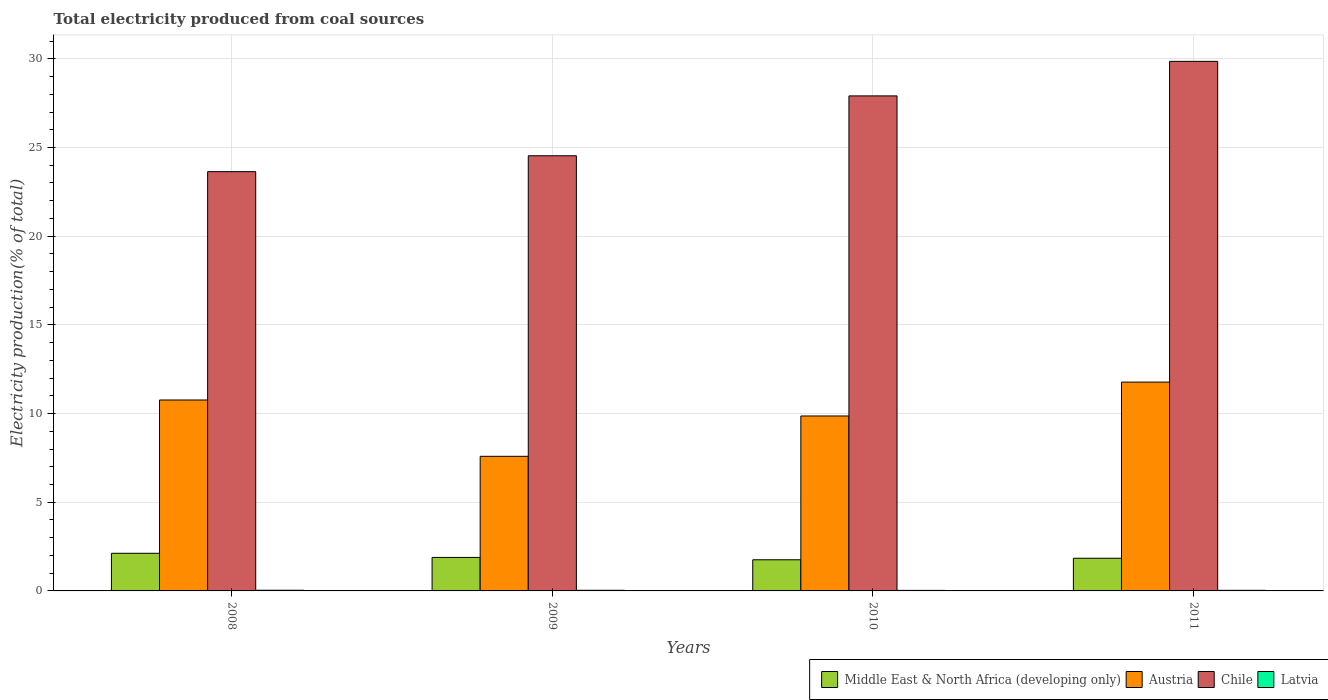Are the number of bars per tick equal to the number of legend labels?
Keep it short and to the point. Yes. Are the number of bars on each tick of the X-axis equal?
Ensure brevity in your answer.  Yes. How many bars are there on the 4th tick from the left?
Provide a succinct answer. 4. What is the label of the 3rd group of bars from the left?
Offer a very short reply. 2010. In how many cases, is the number of bars for a given year not equal to the number of legend labels?
Offer a very short reply. 0. What is the total electricity produced in Middle East & North Africa (developing only) in 2008?
Offer a very short reply. 2.12. Across all years, what is the maximum total electricity produced in Middle East & North Africa (developing only)?
Provide a succinct answer. 2.12. Across all years, what is the minimum total electricity produced in Austria?
Provide a succinct answer. 7.59. What is the total total electricity produced in Austria in the graph?
Your answer should be very brief. 39.99. What is the difference between the total electricity produced in Latvia in 2009 and that in 2011?
Ensure brevity in your answer.  0. What is the difference between the total electricity produced in Latvia in 2008 and the total electricity produced in Austria in 2009?
Provide a succinct answer. -7.55. What is the average total electricity produced in Latvia per year?
Your response must be concise. 0.03. In the year 2010, what is the difference between the total electricity produced in Middle East & North Africa (developing only) and total electricity produced in Chile?
Make the answer very short. -26.15. In how many years, is the total electricity produced in Latvia greater than 6 %?
Make the answer very short. 0. What is the ratio of the total electricity produced in Middle East & North Africa (developing only) in 2009 to that in 2011?
Your response must be concise. 1.03. Is the total electricity produced in Latvia in 2008 less than that in 2009?
Your response must be concise. No. What is the difference between the highest and the second highest total electricity produced in Austria?
Your response must be concise. 1.01. What is the difference between the highest and the lowest total electricity produced in Austria?
Offer a very short reply. 4.18. In how many years, is the total electricity produced in Latvia greater than the average total electricity produced in Latvia taken over all years?
Offer a very short reply. 2. Is it the case that in every year, the sum of the total electricity produced in Austria and total electricity produced in Chile is greater than the sum of total electricity produced in Middle East & North Africa (developing only) and total electricity produced in Latvia?
Keep it short and to the point. No. What does the 2nd bar from the left in 2008 represents?
Your response must be concise. Austria. What does the 1st bar from the right in 2008 represents?
Your answer should be compact. Latvia. Is it the case that in every year, the sum of the total electricity produced in Latvia and total electricity produced in Chile is greater than the total electricity produced in Austria?
Ensure brevity in your answer.  Yes. How many bars are there?
Offer a very short reply. 16. Are the values on the major ticks of Y-axis written in scientific E-notation?
Your answer should be compact. No. Does the graph contain any zero values?
Offer a very short reply. No. Where does the legend appear in the graph?
Give a very brief answer. Bottom right. What is the title of the graph?
Keep it short and to the point. Total electricity produced from coal sources. What is the label or title of the X-axis?
Ensure brevity in your answer.  Years. What is the Electricity production(% of total) in Middle East & North Africa (developing only) in 2008?
Your answer should be very brief. 2.12. What is the Electricity production(% of total) of Austria in 2008?
Provide a short and direct response. 10.76. What is the Electricity production(% of total) in Chile in 2008?
Give a very brief answer. 23.64. What is the Electricity production(% of total) in Latvia in 2008?
Offer a very short reply. 0.04. What is the Electricity production(% of total) in Middle East & North Africa (developing only) in 2009?
Provide a succinct answer. 1.89. What is the Electricity production(% of total) of Austria in 2009?
Your response must be concise. 7.59. What is the Electricity production(% of total) of Chile in 2009?
Keep it short and to the point. 24.53. What is the Electricity production(% of total) of Latvia in 2009?
Give a very brief answer. 0.04. What is the Electricity production(% of total) in Middle East & North Africa (developing only) in 2010?
Your response must be concise. 1.76. What is the Electricity production(% of total) of Austria in 2010?
Ensure brevity in your answer.  9.86. What is the Electricity production(% of total) of Chile in 2010?
Give a very brief answer. 27.91. What is the Electricity production(% of total) of Latvia in 2010?
Offer a terse response. 0.03. What is the Electricity production(% of total) of Middle East & North Africa (developing only) in 2011?
Provide a short and direct response. 1.84. What is the Electricity production(% of total) of Austria in 2011?
Provide a succinct answer. 11.77. What is the Electricity production(% of total) in Chile in 2011?
Make the answer very short. 29.86. What is the Electricity production(% of total) of Latvia in 2011?
Provide a short and direct response. 0.03. Across all years, what is the maximum Electricity production(% of total) of Middle East & North Africa (developing only)?
Your response must be concise. 2.12. Across all years, what is the maximum Electricity production(% of total) in Austria?
Make the answer very short. 11.77. Across all years, what is the maximum Electricity production(% of total) of Chile?
Make the answer very short. 29.86. Across all years, what is the maximum Electricity production(% of total) of Latvia?
Provide a succinct answer. 0.04. Across all years, what is the minimum Electricity production(% of total) of Middle East & North Africa (developing only)?
Provide a short and direct response. 1.76. Across all years, what is the minimum Electricity production(% of total) of Austria?
Your answer should be very brief. 7.59. Across all years, what is the minimum Electricity production(% of total) in Chile?
Your response must be concise. 23.64. Across all years, what is the minimum Electricity production(% of total) in Latvia?
Make the answer very short. 0.03. What is the total Electricity production(% of total) of Middle East & North Africa (developing only) in the graph?
Ensure brevity in your answer.  7.61. What is the total Electricity production(% of total) of Austria in the graph?
Your answer should be compact. 39.99. What is the total Electricity production(% of total) of Chile in the graph?
Your answer should be compact. 105.93. What is the total Electricity production(% of total) in Latvia in the graph?
Provide a succinct answer. 0.14. What is the difference between the Electricity production(% of total) of Middle East & North Africa (developing only) in 2008 and that in 2009?
Your answer should be compact. 0.23. What is the difference between the Electricity production(% of total) in Austria in 2008 and that in 2009?
Offer a very short reply. 3.18. What is the difference between the Electricity production(% of total) of Chile in 2008 and that in 2009?
Your response must be concise. -0.9. What is the difference between the Electricity production(% of total) of Latvia in 2008 and that in 2009?
Keep it short and to the point. 0. What is the difference between the Electricity production(% of total) of Middle East & North Africa (developing only) in 2008 and that in 2010?
Ensure brevity in your answer.  0.37. What is the difference between the Electricity production(% of total) of Austria in 2008 and that in 2010?
Your response must be concise. 0.9. What is the difference between the Electricity production(% of total) in Chile in 2008 and that in 2010?
Offer a terse response. -4.27. What is the difference between the Electricity production(% of total) of Latvia in 2008 and that in 2010?
Your response must be concise. 0.01. What is the difference between the Electricity production(% of total) of Middle East & North Africa (developing only) in 2008 and that in 2011?
Your answer should be very brief. 0.28. What is the difference between the Electricity production(% of total) in Austria in 2008 and that in 2011?
Offer a terse response. -1.01. What is the difference between the Electricity production(% of total) of Chile in 2008 and that in 2011?
Your answer should be very brief. -6.22. What is the difference between the Electricity production(% of total) of Latvia in 2008 and that in 2011?
Offer a terse response. 0.01. What is the difference between the Electricity production(% of total) of Middle East & North Africa (developing only) in 2009 and that in 2010?
Your answer should be very brief. 0.13. What is the difference between the Electricity production(% of total) of Austria in 2009 and that in 2010?
Give a very brief answer. -2.27. What is the difference between the Electricity production(% of total) of Chile in 2009 and that in 2010?
Offer a very short reply. -3.38. What is the difference between the Electricity production(% of total) of Latvia in 2009 and that in 2010?
Your response must be concise. 0.01. What is the difference between the Electricity production(% of total) in Middle East & North Africa (developing only) in 2009 and that in 2011?
Ensure brevity in your answer.  0.05. What is the difference between the Electricity production(% of total) of Austria in 2009 and that in 2011?
Your answer should be compact. -4.18. What is the difference between the Electricity production(% of total) of Chile in 2009 and that in 2011?
Give a very brief answer. -5.32. What is the difference between the Electricity production(% of total) in Latvia in 2009 and that in 2011?
Provide a succinct answer. 0. What is the difference between the Electricity production(% of total) in Middle East & North Africa (developing only) in 2010 and that in 2011?
Your answer should be compact. -0.09. What is the difference between the Electricity production(% of total) of Austria in 2010 and that in 2011?
Provide a short and direct response. -1.91. What is the difference between the Electricity production(% of total) in Chile in 2010 and that in 2011?
Give a very brief answer. -1.95. What is the difference between the Electricity production(% of total) of Latvia in 2010 and that in 2011?
Make the answer very short. -0. What is the difference between the Electricity production(% of total) in Middle East & North Africa (developing only) in 2008 and the Electricity production(% of total) in Austria in 2009?
Your answer should be compact. -5.47. What is the difference between the Electricity production(% of total) of Middle East & North Africa (developing only) in 2008 and the Electricity production(% of total) of Chile in 2009?
Ensure brevity in your answer.  -22.41. What is the difference between the Electricity production(% of total) in Middle East & North Africa (developing only) in 2008 and the Electricity production(% of total) in Latvia in 2009?
Your answer should be very brief. 2.09. What is the difference between the Electricity production(% of total) in Austria in 2008 and the Electricity production(% of total) in Chile in 2009?
Ensure brevity in your answer.  -13.77. What is the difference between the Electricity production(% of total) of Austria in 2008 and the Electricity production(% of total) of Latvia in 2009?
Offer a terse response. 10.73. What is the difference between the Electricity production(% of total) of Chile in 2008 and the Electricity production(% of total) of Latvia in 2009?
Offer a terse response. 23.6. What is the difference between the Electricity production(% of total) in Middle East & North Africa (developing only) in 2008 and the Electricity production(% of total) in Austria in 2010?
Provide a short and direct response. -7.74. What is the difference between the Electricity production(% of total) in Middle East & North Africa (developing only) in 2008 and the Electricity production(% of total) in Chile in 2010?
Give a very brief answer. -25.79. What is the difference between the Electricity production(% of total) in Middle East & North Africa (developing only) in 2008 and the Electricity production(% of total) in Latvia in 2010?
Your answer should be compact. 2.09. What is the difference between the Electricity production(% of total) in Austria in 2008 and the Electricity production(% of total) in Chile in 2010?
Your response must be concise. -17.14. What is the difference between the Electricity production(% of total) in Austria in 2008 and the Electricity production(% of total) in Latvia in 2010?
Your response must be concise. 10.73. What is the difference between the Electricity production(% of total) in Chile in 2008 and the Electricity production(% of total) in Latvia in 2010?
Ensure brevity in your answer.  23.61. What is the difference between the Electricity production(% of total) in Middle East & North Africa (developing only) in 2008 and the Electricity production(% of total) in Austria in 2011?
Your answer should be compact. -9.65. What is the difference between the Electricity production(% of total) in Middle East & North Africa (developing only) in 2008 and the Electricity production(% of total) in Chile in 2011?
Make the answer very short. -27.73. What is the difference between the Electricity production(% of total) of Middle East & North Africa (developing only) in 2008 and the Electricity production(% of total) of Latvia in 2011?
Keep it short and to the point. 2.09. What is the difference between the Electricity production(% of total) of Austria in 2008 and the Electricity production(% of total) of Chile in 2011?
Offer a terse response. -19.09. What is the difference between the Electricity production(% of total) in Austria in 2008 and the Electricity production(% of total) in Latvia in 2011?
Your answer should be compact. 10.73. What is the difference between the Electricity production(% of total) of Chile in 2008 and the Electricity production(% of total) of Latvia in 2011?
Offer a terse response. 23.6. What is the difference between the Electricity production(% of total) of Middle East & North Africa (developing only) in 2009 and the Electricity production(% of total) of Austria in 2010?
Give a very brief answer. -7.97. What is the difference between the Electricity production(% of total) in Middle East & North Africa (developing only) in 2009 and the Electricity production(% of total) in Chile in 2010?
Your response must be concise. -26.02. What is the difference between the Electricity production(% of total) of Middle East & North Africa (developing only) in 2009 and the Electricity production(% of total) of Latvia in 2010?
Provide a short and direct response. 1.86. What is the difference between the Electricity production(% of total) of Austria in 2009 and the Electricity production(% of total) of Chile in 2010?
Offer a terse response. -20.32. What is the difference between the Electricity production(% of total) in Austria in 2009 and the Electricity production(% of total) in Latvia in 2010?
Your answer should be compact. 7.56. What is the difference between the Electricity production(% of total) of Chile in 2009 and the Electricity production(% of total) of Latvia in 2010?
Ensure brevity in your answer.  24.5. What is the difference between the Electricity production(% of total) in Middle East & North Africa (developing only) in 2009 and the Electricity production(% of total) in Austria in 2011?
Ensure brevity in your answer.  -9.88. What is the difference between the Electricity production(% of total) of Middle East & North Africa (developing only) in 2009 and the Electricity production(% of total) of Chile in 2011?
Offer a very short reply. -27.97. What is the difference between the Electricity production(% of total) in Middle East & North Africa (developing only) in 2009 and the Electricity production(% of total) in Latvia in 2011?
Provide a short and direct response. 1.86. What is the difference between the Electricity production(% of total) in Austria in 2009 and the Electricity production(% of total) in Chile in 2011?
Your answer should be very brief. -22.27. What is the difference between the Electricity production(% of total) of Austria in 2009 and the Electricity production(% of total) of Latvia in 2011?
Your answer should be very brief. 7.56. What is the difference between the Electricity production(% of total) in Chile in 2009 and the Electricity production(% of total) in Latvia in 2011?
Provide a short and direct response. 24.5. What is the difference between the Electricity production(% of total) of Middle East & North Africa (developing only) in 2010 and the Electricity production(% of total) of Austria in 2011?
Provide a short and direct response. -10.02. What is the difference between the Electricity production(% of total) of Middle East & North Africa (developing only) in 2010 and the Electricity production(% of total) of Chile in 2011?
Ensure brevity in your answer.  -28.1. What is the difference between the Electricity production(% of total) in Middle East & North Africa (developing only) in 2010 and the Electricity production(% of total) in Latvia in 2011?
Your answer should be compact. 1.72. What is the difference between the Electricity production(% of total) in Austria in 2010 and the Electricity production(% of total) in Chile in 2011?
Give a very brief answer. -19.99. What is the difference between the Electricity production(% of total) in Austria in 2010 and the Electricity production(% of total) in Latvia in 2011?
Offer a very short reply. 9.83. What is the difference between the Electricity production(% of total) in Chile in 2010 and the Electricity production(% of total) in Latvia in 2011?
Your answer should be very brief. 27.88. What is the average Electricity production(% of total) in Middle East & North Africa (developing only) per year?
Offer a very short reply. 1.9. What is the average Electricity production(% of total) in Austria per year?
Your response must be concise. 10. What is the average Electricity production(% of total) in Chile per year?
Ensure brevity in your answer.  26.48. What is the average Electricity production(% of total) in Latvia per year?
Your response must be concise. 0.03. In the year 2008, what is the difference between the Electricity production(% of total) of Middle East & North Africa (developing only) and Electricity production(% of total) of Austria?
Your answer should be compact. -8.64. In the year 2008, what is the difference between the Electricity production(% of total) in Middle East & North Africa (developing only) and Electricity production(% of total) in Chile?
Keep it short and to the point. -21.51. In the year 2008, what is the difference between the Electricity production(% of total) of Middle East & North Africa (developing only) and Electricity production(% of total) of Latvia?
Your answer should be very brief. 2.08. In the year 2008, what is the difference between the Electricity production(% of total) in Austria and Electricity production(% of total) in Chile?
Provide a succinct answer. -12.87. In the year 2008, what is the difference between the Electricity production(% of total) in Austria and Electricity production(% of total) in Latvia?
Offer a terse response. 10.73. In the year 2008, what is the difference between the Electricity production(% of total) in Chile and Electricity production(% of total) in Latvia?
Make the answer very short. 23.6. In the year 2009, what is the difference between the Electricity production(% of total) of Middle East & North Africa (developing only) and Electricity production(% of total) of Austria?
Your answer should be compact. -5.7. In the year 2009, what is the difference between the Electricity production(% of total) in Middle East & North Africa (developing only) and Electricity production(% of total) in Chile?
Give a very brief answer. -22.64. In the year 2009, what is the difference between the Electricity production(% of total) of Middle East & North Africa (developing only) and Electricity production(% of total) of Latvia?
Make the answer very short. 1.85. In the year 2009, what is the difference between the Electricity production(% of total) in Austria and Electricity production(% of total) in Chile?
Your answer should be very brief. -16.95. In the year 2009, what is the difference between the Electricity production(% of total) of Austria and Electricity production(% of total) of Latvia?
Offer a terse response. 7.55. In the year 2009, what is the difference between the Electricity production(% of total) of Chile and Electricity production(% of total) of Latvia?
Offer a very short reply. 24.5. In the year 2010, what is the difference between the Electricity production(% of total) in Middle East & North Africa (developing only) and Electricity production(% of total) in Austria?
Give a very brief answer. -8.11. In the year 2010, what is the difference between the Electricity production(% of total) of Middle East & North Africa (developing only) and Electricity production(% of total) of Chile?
Ensure brevity in your answer.  -26.15. In the year 2010, what is the difference between the Electricity production(% of total) in Middle East & North Africa (developing only) and Electricity production(% of total) in Latvia?
Make the answer very short. 1.73. In the year 2010, what is the difference between the Electricity production(% of total) in Austria and Electricity production(% of total) in Chile?
Your answer should be very brief. -18.05. In the year 2010, what is the difference between the Electricity production(% of total) of Austria and Electricity production(% of total) of Latvia?
Offer a very short reply. 9.83. In the year 2010, what is the difference between the Electricity production(% of total) in Chile and Electricity production(% of total) in Latvia?
Your answer should be compact. 27.88. In the year 2011, what is the difference between the Electricity production(% of total) of Middle East & North Africa (developing only) and Electricity production(% of total) of Austria?
Your response must be concise. -9.93. In the year 2011, what is the difference between the Electricity production(% of total) of Middle East & North Africa (developing only) and Electricity production(% of total) of Chile?
Your response must be concise. -28.01. In the year 2011, what is the difference between the Electricity production(% of total) of Middle East & North Africa (developing only) and Electricity production(% of total) of Latvia?
Give a very brief answer. 1.81. In the year 2011, what is the difference between the Electricity production(% of total) of Austria and Electricity production(% of total) of Chile?
Your answer should be compact. -18.08. In the year 2011, what is the difference between the Electricity production(% of total) of Austria and Electricity production(% of total) of Latvia?
Give a very brief answer. 11.74. In the year 2011, what is the difference between the Electricity production(% of total) of Chile and Electricity production(% of total) of Latvia?
Give a very brief answer. 29.82. What is the ratio of the Electricity production(% of total) in Middle East & North Africa (developing only) in 2008 to that in 2009?
Provide a succinct answer. 1.12. What is the ratio of the Electricity production(% of total) in Austria in 2008 to that in 2009?
Your response must be concise. 1.42. What is the ratio of the Electricity production(% of total) of Chile in 2008 to that in 2009?
Provide a succinct answer. 0.96. What is the ratio of the Electricity production(% of total) in Latvia in 2008 to that in 2009?
Provide a succinct answer. 1.06. What is the ratio of the Electricity production(% of total) of Middle East & North Africa (developing only) in 2008 to that in 2010?
Your answer should be compact. 1.21. What is the ratio of the Electricity production(% of total) in Austria in 2008 to that in 2010?
Keep it short and to the point. 1.09. What is the ratio of the Electricity production(% of total) of Chile in 2008 to that in 2010?
Make the answer very short. 0.85. What is the ratio of the Electricity production(% of total) of Latvia in 2008 to that in 2010?
Provide a succinct answer. 1.26. What is the ratio of the Electricity production(% of total) of Middle East & North Africa (developing only) in 2008 to that in 2011?
Provide a succinct answer. 1.15. What is the ratio of the Electricity production(% of total) in Austria in 2008 to that in 2011?
Offer a very short reply. 0.91. What is the ratio of the Electricity production(% of total) of Chile in 2008 to that in 2011?
Provide a succinct answer. 0.79. What is the ratio of the Electricity production(% of total) of Latvia in 2008 to that in 2011?
Keep it short and to the point. 1.16. What is the ratio of the Electricity production(% of total) of Middle East & North Africa (developing only) in 2009 to that in 2010?
Make the answer very short. 1.08. What is the ratio of the Electricity production(% of total) in Austria in 2009 to that in 2010?
Make the answer very short. 0.77. What is the ratio of the Electricity production(% of total) of Chile in 2009 to that in 2010?
Give a very brief answer. 0.88. What is the ratio of the Electricity production(% of total) of Latvia in 2009 to that in 2010?
Your answer should be compact. 1.19. What is the ratio of the Electricity production(% of total) in Middle East & North Africa (developing only) in 2009 to that in 2011?
Provide a succinct answer. 1.02. What is the ratio of the Electricity production(% of total) in Austria in 2009 to that in 2011?
Your response must be concise. 0.64. What is the ratio of the Electricity production(% of total) in Chile in 2009 to that in 2011?
Your answer should be very brief. 0.82. What is the ratio of the Electricity production(% of total) of Latvia in 2009 to that in 2011?
Give a very brief answer. 1.09. What is the ratio of the Electricity production(% of total) of Middle East & North Africa (developing only) in 2010 to that in 2011?
Provide a short and direct response. 0.95. What is the ratio of the Electricity production(% of total) of Austria in 2010 to that in 2011?
Offer a very short reply. 0.84. What is the ratio of the Electricity production(% of total) in Chile in 2010 to that in 2011?
Make the answer very short. 0.93. What is the ratio of the Electricity production(% of total) of Latvia in 2010 to that in 2011?
Make the answer very short. 0.92. What is the difference between the highest and the second highest Electricity production(% of total) of Middle East & North Africa (developing only)?
Ensure brevity in your answer.  0.23. What is the difference between the highest and the second highest Electricity production(% of total) in Austria?
Ensure brevity in your answer.  1.01. What is the difference between the highest and the second highest Electricity production(% of total) in Chile?
Offer a terse response. 1.95. What is the difference between the highest and the second highest Electricity production(% of total) in Latvia?
Provide a short and direct response. 0. What is the difference between the highest and the lowest Electricity production(% of total) of Middle East & North Africa (developing only)?
Your answer should be compact. 0.37. What is the difference between the highest and the lowest Electricity production(% of total) in Austria?
Ensure brevity in your answer.  4.18. What is the difference between the highest and the lowest Electricity production(% of total) of Chile?
Keep it short and to the point. 6.22. What is the difference between the highest and the lowest Electricity production(% of total) of Latvia?
Offer a terse response. 0.01. 